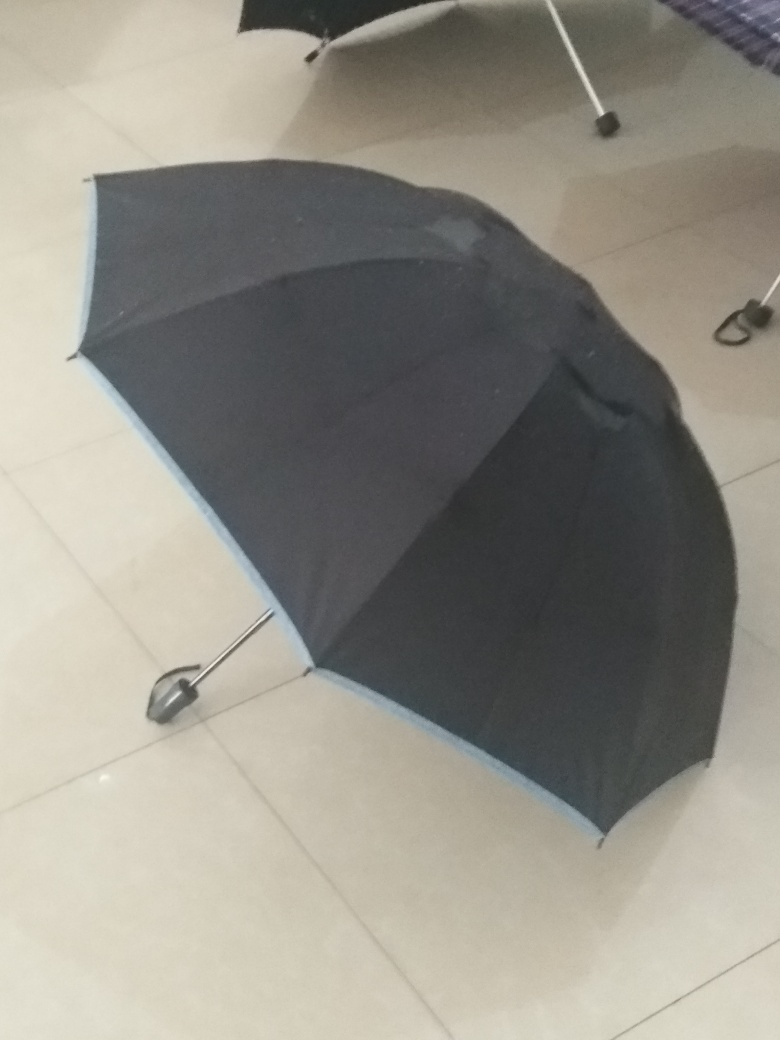Could you speculate on why the umbrella is indoors? There could be several reasons why the umbrella is indoors. It might be drying after use, or it was perhaps brought inside to avoid being blown away if it were windy outside. Alternatively, the owner may have simply left it there temporarily. 